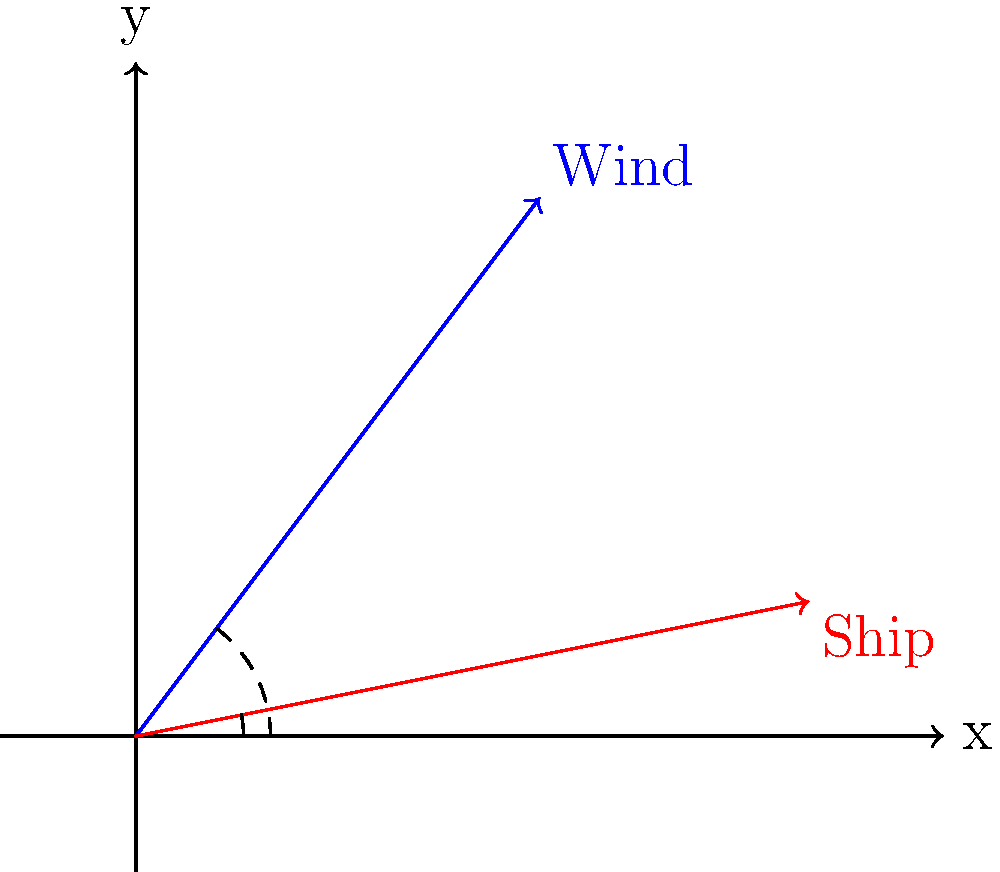In the Sea of Thieves, a ship is sailing with a heading vector of $\vec{v_1} = (5,1)$, while the wind direction is represented by the vector $\vec{v_2} = (3,4)$. Calculate the angle between these two vectors to determine how well the ship is positioned relative to the wind. Round your answer to the nearest degree. Let's approach this step-by-step, as if we were planning our route in Sea of Thieves:

1) To find the angle between two vectors, we can use the dot product formula:

   $\cos \theta = \frac{\vec{v_1} \cdot \vec{v_2}}{|\vec{v_1}| |\vec{v_2}|}$

2) First, let's calculate the dot product $\vec{v_1} \cdot \vec{v_2}$:
   $\vec{v_1} \cdot \vec{v_2} = (5)(3) + (1)(4) = 15 + 4 = 19$

3) Next, we need to calculate the magnitudes of the vectors:
   $|\vec{v_1}| = \sqrt{5^2 + 1^2} = \sqrt{26}$
   $|\vec{v_2}| = \sqrt{3^2 + 4^2} = 5$

4) Now we can plug these values into our formula:
   $\cos \theta = \frac{19}{\sqrt{26} \cdot 5}$

5) To get $\theta$, we need to take the inverse cosine (arccos) of both sides:
   $\theta = \arccos(\frac{19}{\sqrt{26} \cdot 5})$

6) Using a calculator and rounding to the nearest degree:
   $\theta \approx 44°$

This angle tells us how far off our ship's heading is from the wind direction, crucial information for any Sea of Thieves sailor!
Answer: 44° 